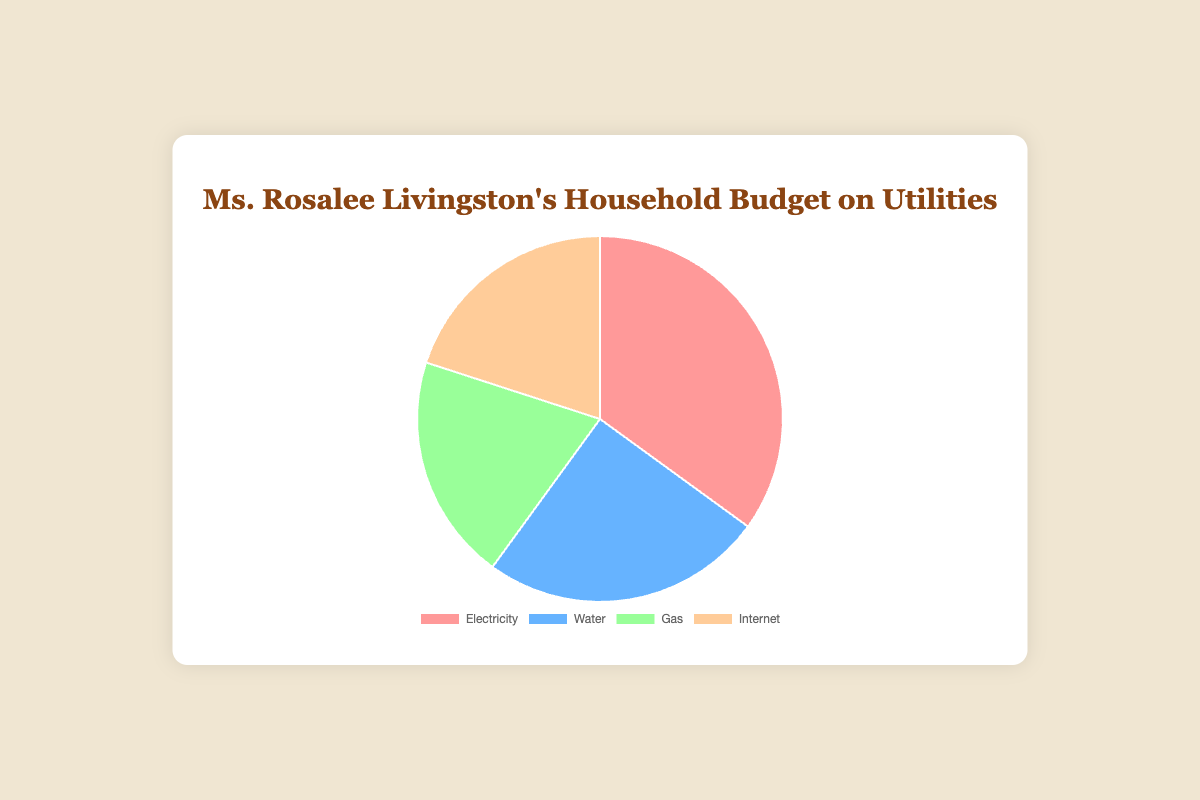What is the percentage allocation for Electricity? Referring to the pie chart, you can see that the slice representing Electricity is marked as 35%.
Answer: 35% Which utility has the smallest percentage allocation? By examining the chart, both Gas and Internet show a 20% allocation, indicating they share the smallest allocation.
Answer: Gas and Internet What is the total percentage allocation for Gas and Internet combined? Both Gas and Internet have an allocation of 20%. Adding them together gives 20% + 20% = 40%.
Answer: 40% Is the allocation for Water greater or less than that for Electricity? The pie chart shows Water has a 25% allocation and Electricity has a 35% allocation, meaning Water's allocation is less than Electricity's.
Answer: Less than Which utility is represented by the blue slice in the pie chart? The pie chart indicates that the blue slice corresponds to Water.
Answer: Water What is the difference in percentage between the highest and lowest utility allocations? The highest allocation is for Electricity at 35%, and the lowest is for both Gas and Internet at 20%. The difference is 35% - 20% = 15%.
Answer: 15% How many utilities share exactly 20% of the budget? Observing the pie chart, Gas and Internet both have a 20% allocation. Thus, there are 2 utilities sharing this budget percentage.
Answer: 2 What is the combined allocation percentage for utilities other than Electricity? The allocations for Water, Gas, and Internet are 25%, 20%, and 20% respectively. Adding these together gives 25% + 20% + 20% = 65%.
Answer: 65% Which utility has the second largest allocation in the household budget? The pie chart shows that Water has a 25% allocation, which is the second-largest after Electricity at 35%.
Answer: Water If the budget were adjusted so that each utility had an equal percentage, what would the allocation be for each utility? Given that there are four utilities, if each had an equal share of the budget, the total percentage (100%) would be divided by four. Hence, each utility would have 100% / 4 = 25%.
Answer: 25% 